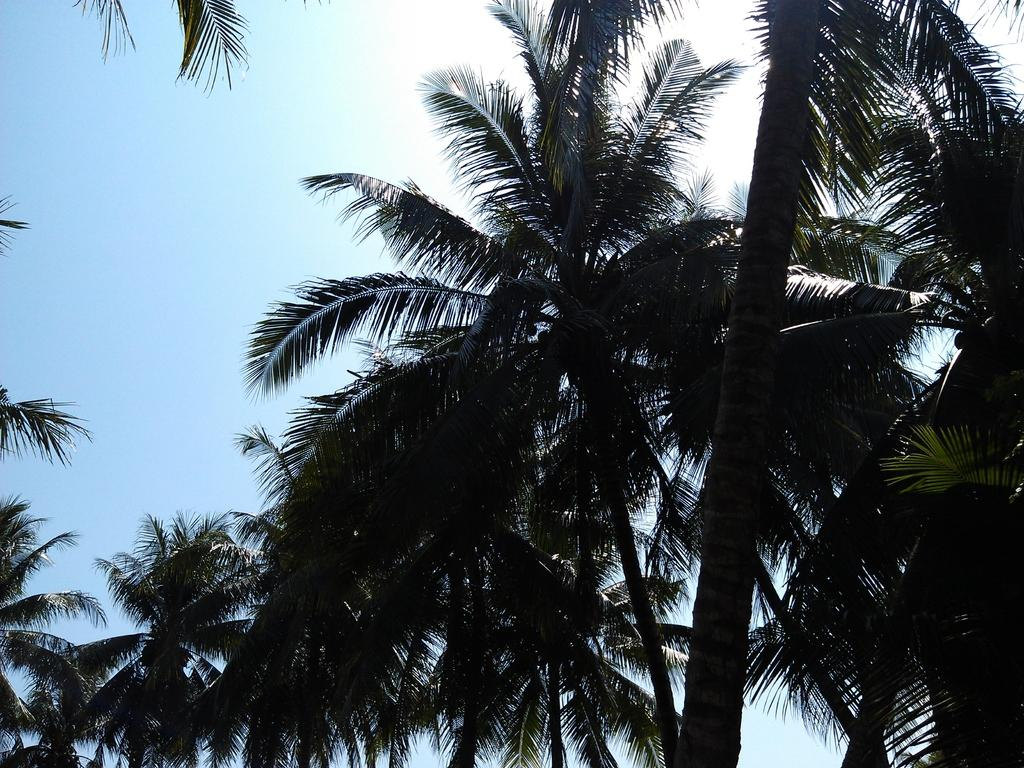What type of vegetation can be seen in the image? There are trees in the image. Where are the trees located in relation to the image? The trees are at the front of the image. What else can be seen in the image besides the trees? The sky is visible in the image. Where is the sky located in relation to the image? The sky is at the back of the image. What type of crate is visible in the image? There is no crate present in the image. What sign can be seen hanging from the trees in the image? There is no sign hanging from the trees in the image. 